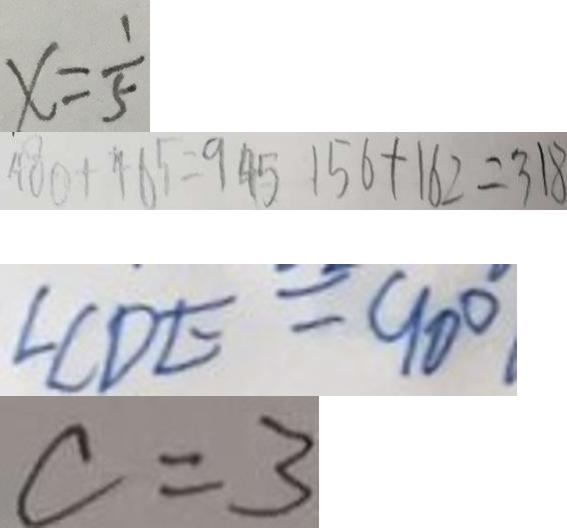<formula> <loc_0><loc_0><loc_500><loc_500>x = \frac { 1 } { 5 } 
 4 0 0 + 4 6 5 = 9 4 5 1 5 6 + 1 6 2 = 3 1 8 
 \angle C D E = 9 0 ^ { \circ } . 
 c = 3</formula> 